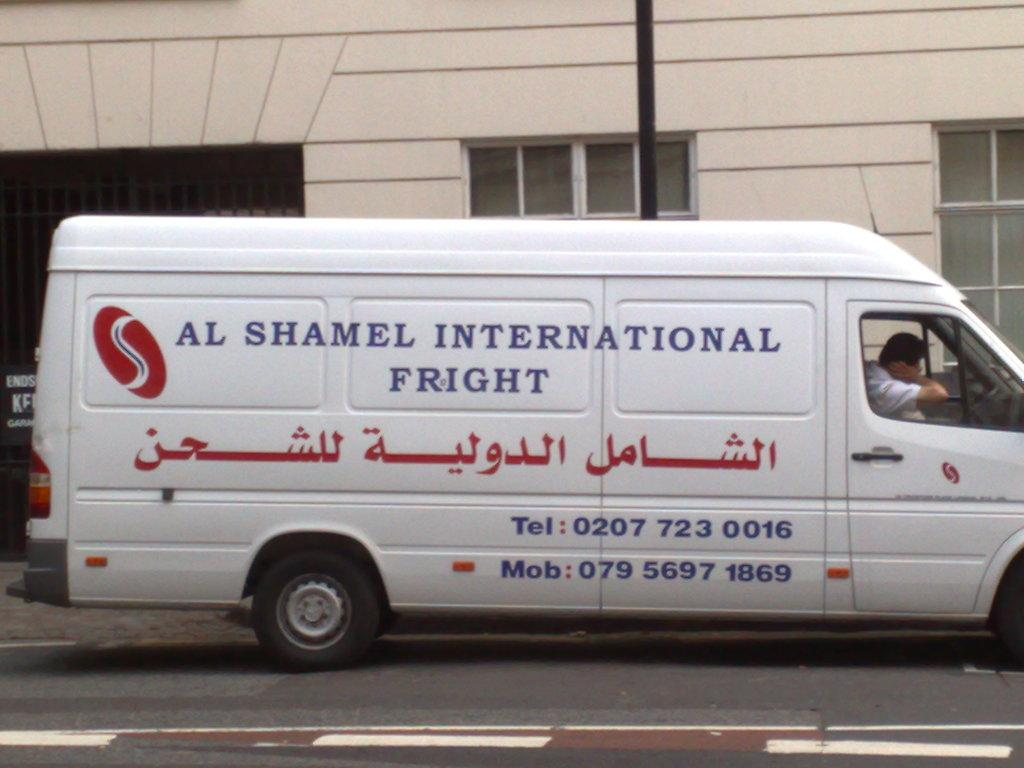<image>
Offer a succinct explanation of the picture presented. A white freight van that says Al Shamel International Fright. 